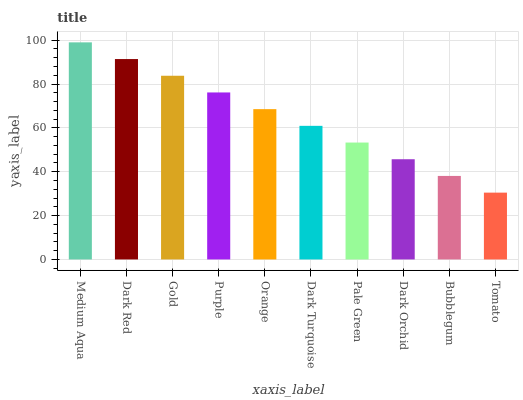Is Dark Red the minimum?
Answer yes or no. No. Is Dark Red the maximum?
Answer yes or no. No. Is Medium Aqua greater than Dark Red?
Answer yes or no. Yes. Is Dark Red less than Medium Aqua?
Answer yes or no. Yes. Is Dark Red greater than Medium Aqua?
Answer yes or no. No. Is Medium Aqua less than Dark Red?
Answer yes or no. No. Is Orange the high median?
Answer yes or no. Yes. Is Dark Turquoise the low median?
Answer yes or no. Yes. Is Dark Red the high median?
Answer yes or no. No. Is Medium Aqua the low median?
Answer yes or no. No. 